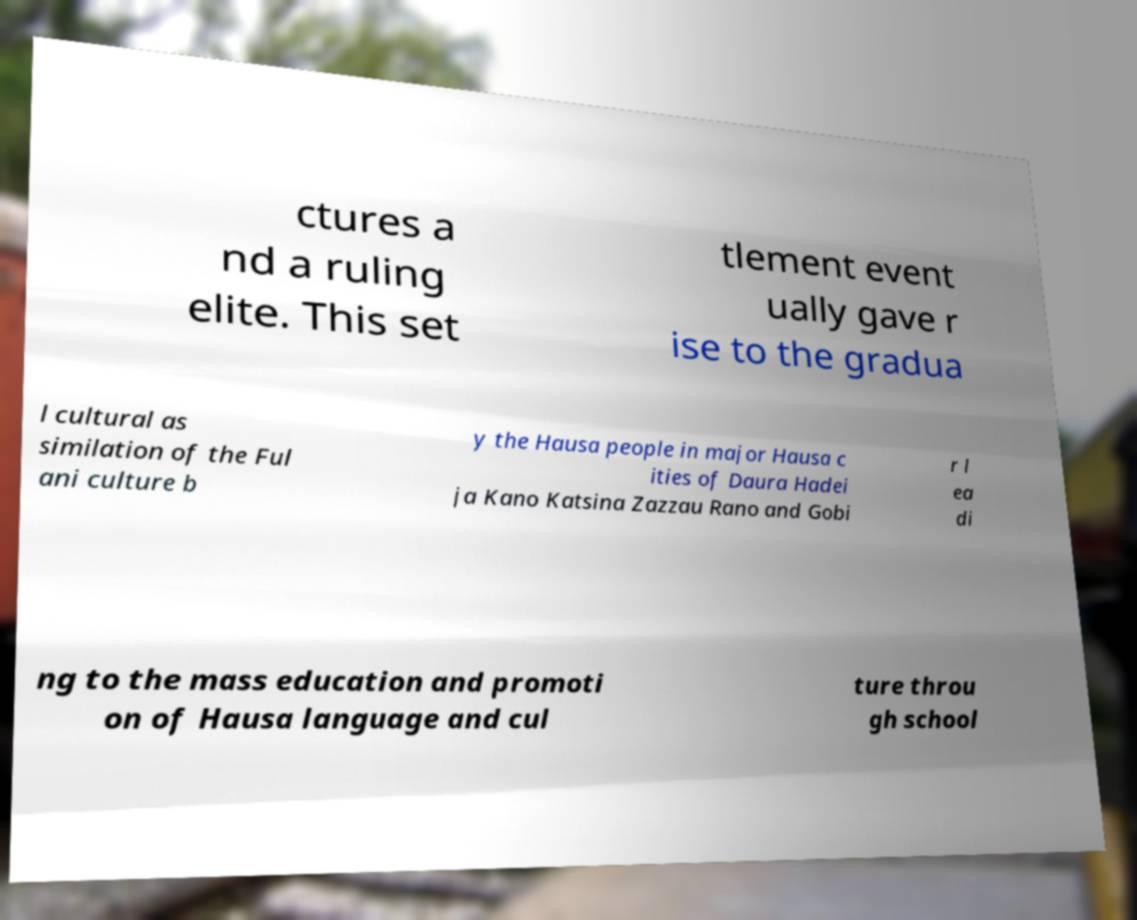Can you accurately transcribe the text from the provided image for me? ctures a nd a ruling elite. This set tlement event ually gave r ise to the gradua l cultural as similation of the Ful ani culture b y the Hausa people in major Hausa c ities of Daura Hadei ja Kano Katsina Zazzau Rano and Gobi r l ea di ng to the mass education and promoti on of Hausa language and cul ture throu gh school 